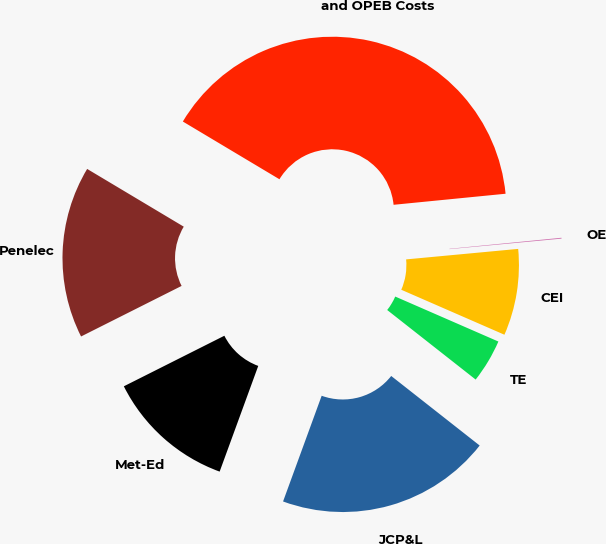Convert chart to OTSL. <chart><loc_0><loc_0><loc_500><loc_500><pie_chart><fcel>and OPEB Costs<fcel>OE<fcel>CEI<fcel>TE<fcel>JCP&L<fcel>Met-Ed<fcel>Penelec<nl><fcel>39.86%<fcel>0.08%<fcel>8.03%<fcel>4.06%<fcel>19.97%<fcel>12.01%<fcel>15.99%<nl></chart> 